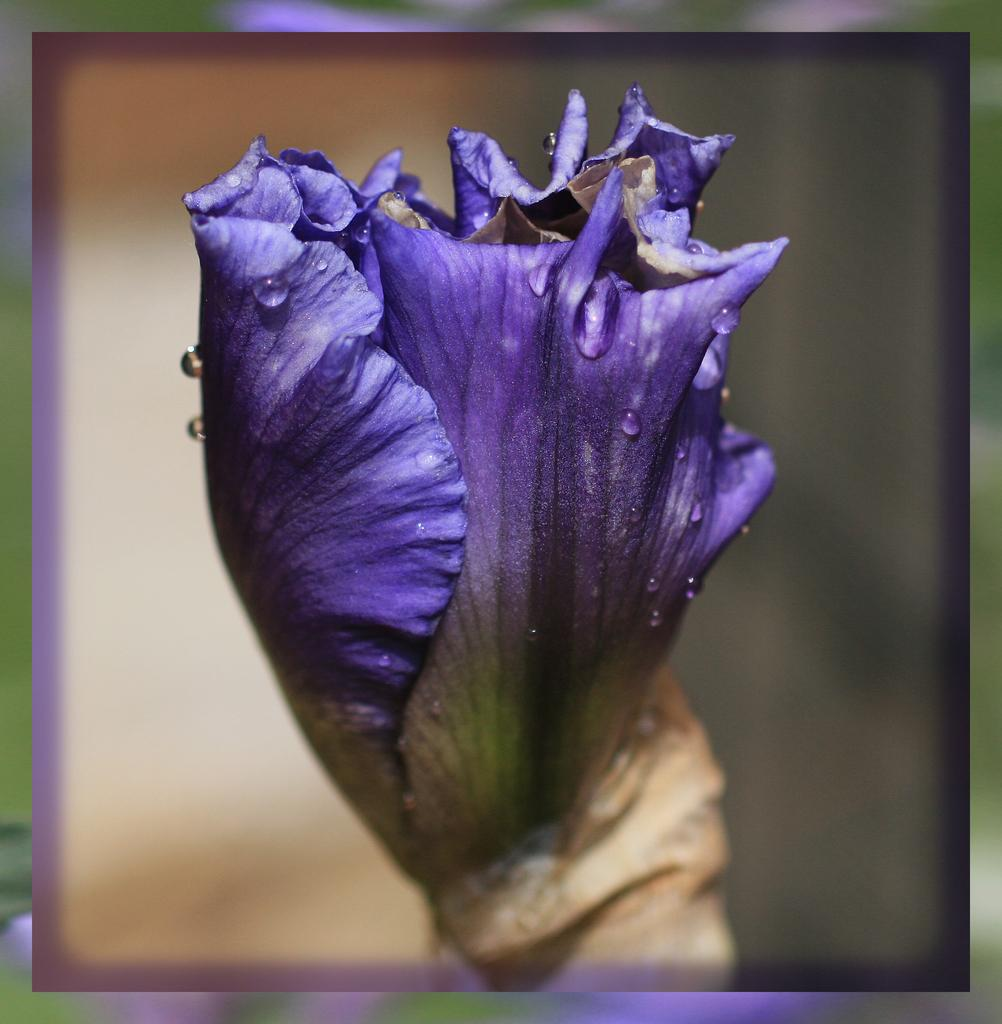What type of flower is in the image? There is a purple color flower in the image. Can you describe the background of the image? The background of the image is blurred. What type of blade is being used in the competition in the image? There is no competition or blade present in the image; it only features a purple color flower with a blurred background. 